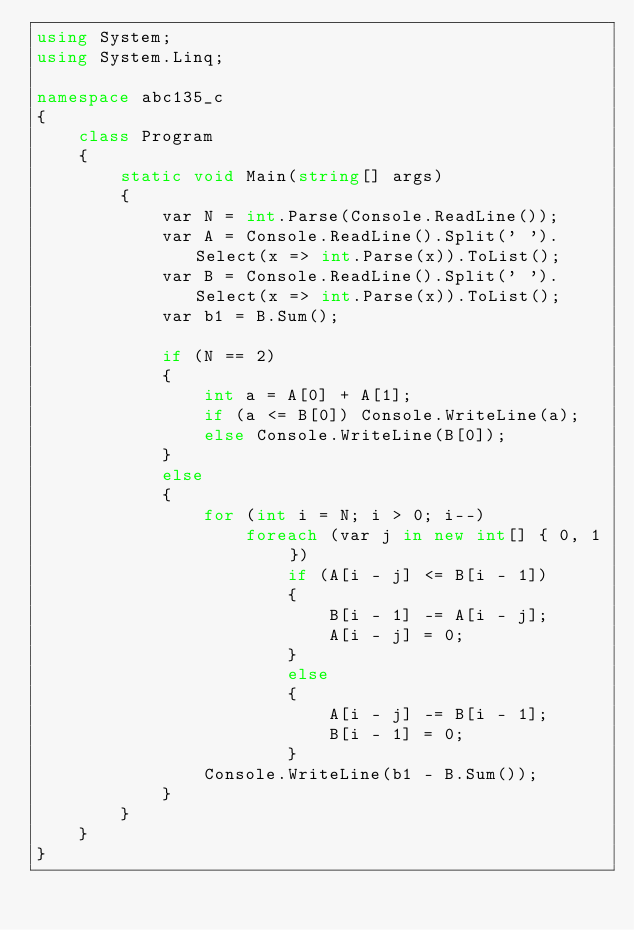Convert code to text. <code><loc_0><loc_0><loc_500><loc_500><_C#_>using System;
using System.Linq;

namespace abc135_c
{
    class Program
    {
        static void Main(string[] args)
        {
            var N = int.Parse(Console.ReadLine());
            var A = Console.ReadLine().Split(' ').Select(x => int.Parse(x)).ToList();
            var B = Console.ReadLine().Split(' ').Select(x => int.Parse(x)).ToList();
            var b1 = B.Sum();

            if (N == 2)
            {
                int a = A[0] + A[1];
                if (a <= B[0]) Console.WriteLine(a);
                else Console.WriteLine(B[0]);
            }
            else
            {
                for (int i = N; i > 0; i--)
                    foreach (var j in new int[] { 0, 1 })
                        if (A[i - j] <= B[i - 1])
                        {
                            B[i - 1] -= A[i - j];
                            A[i - j] = 0;
                        }
                        else
                        {
                            A[i - j] -= B[i - 1];
                            B[i - 1] = 0;
                        }
                Console.WriteLine(b1 - B.Sum());
            }
        }
    }
}
</code> 